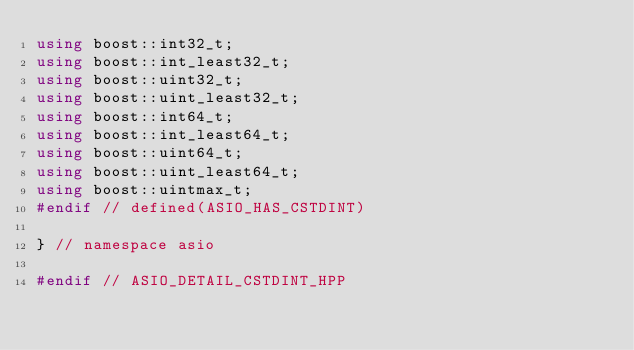Convert code to text. <code><loc_0><loc_0><loc_500><loc_500><_C++_>using boost::int32_t;
using boost::int_least32_t;
using boost::uint32_t;
using boost::uint_least32_t;
using boost::int64_t;
using boost::int_least64_t;
using boost::uint64_t;
using boost::uint_least64_t;
using boost::uintmax_t;
#endif // defined(ASIO_HAS_CSTDINT)

} // namespace asio

#endif // ASIO_DETAIL_CSTDINT_HPP
</code> 